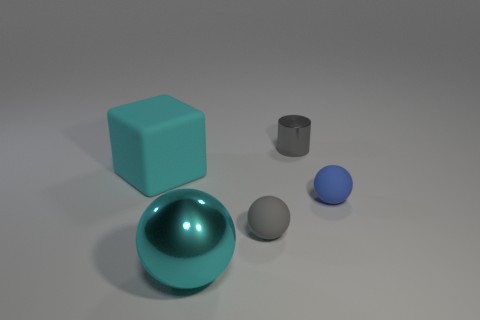Are there an equal number of cyan cubes that are behind the small blue rubber sphere and big metallic objects behind the tiny gray cylinder?
Keep it short and to the point. No. There is a tiny gray object that is in front of the gray metallic thing; are there any small rubber balls in front of it?
Your answer should be very brief. No. The tiny blue thing has what shape?
Give a very brief answer. Sphere. There is another object that is the same color as the large metal object; what is its size?
Ensure brevity in your answer.  Large. What size is the cyan metallic object that is left of the rubber sphere that is to the left of the small gray metal object?
Offer a terse response. Large. What size is the cyan matte cube on the left side of the tiny blue rubber object?
Offer a terse response. Large. Are there fewer large cyan rubber things that are to the right of the tiny blue ball than large cyan rubber things that are behind the gray metallic thing?
Ensure brevity in your answer.  No. What color is the small metallic cylinder?
Give a very brief answer. Gray. Is there a metallic cylinder that has the same color as the shiny sphere?
Give a very brief answer. No. What shape is the cyan object in front of the cyan object that is to the left of the cyan thing in front of the matte block?
Ensure brevity in your answer.  Sphere. 